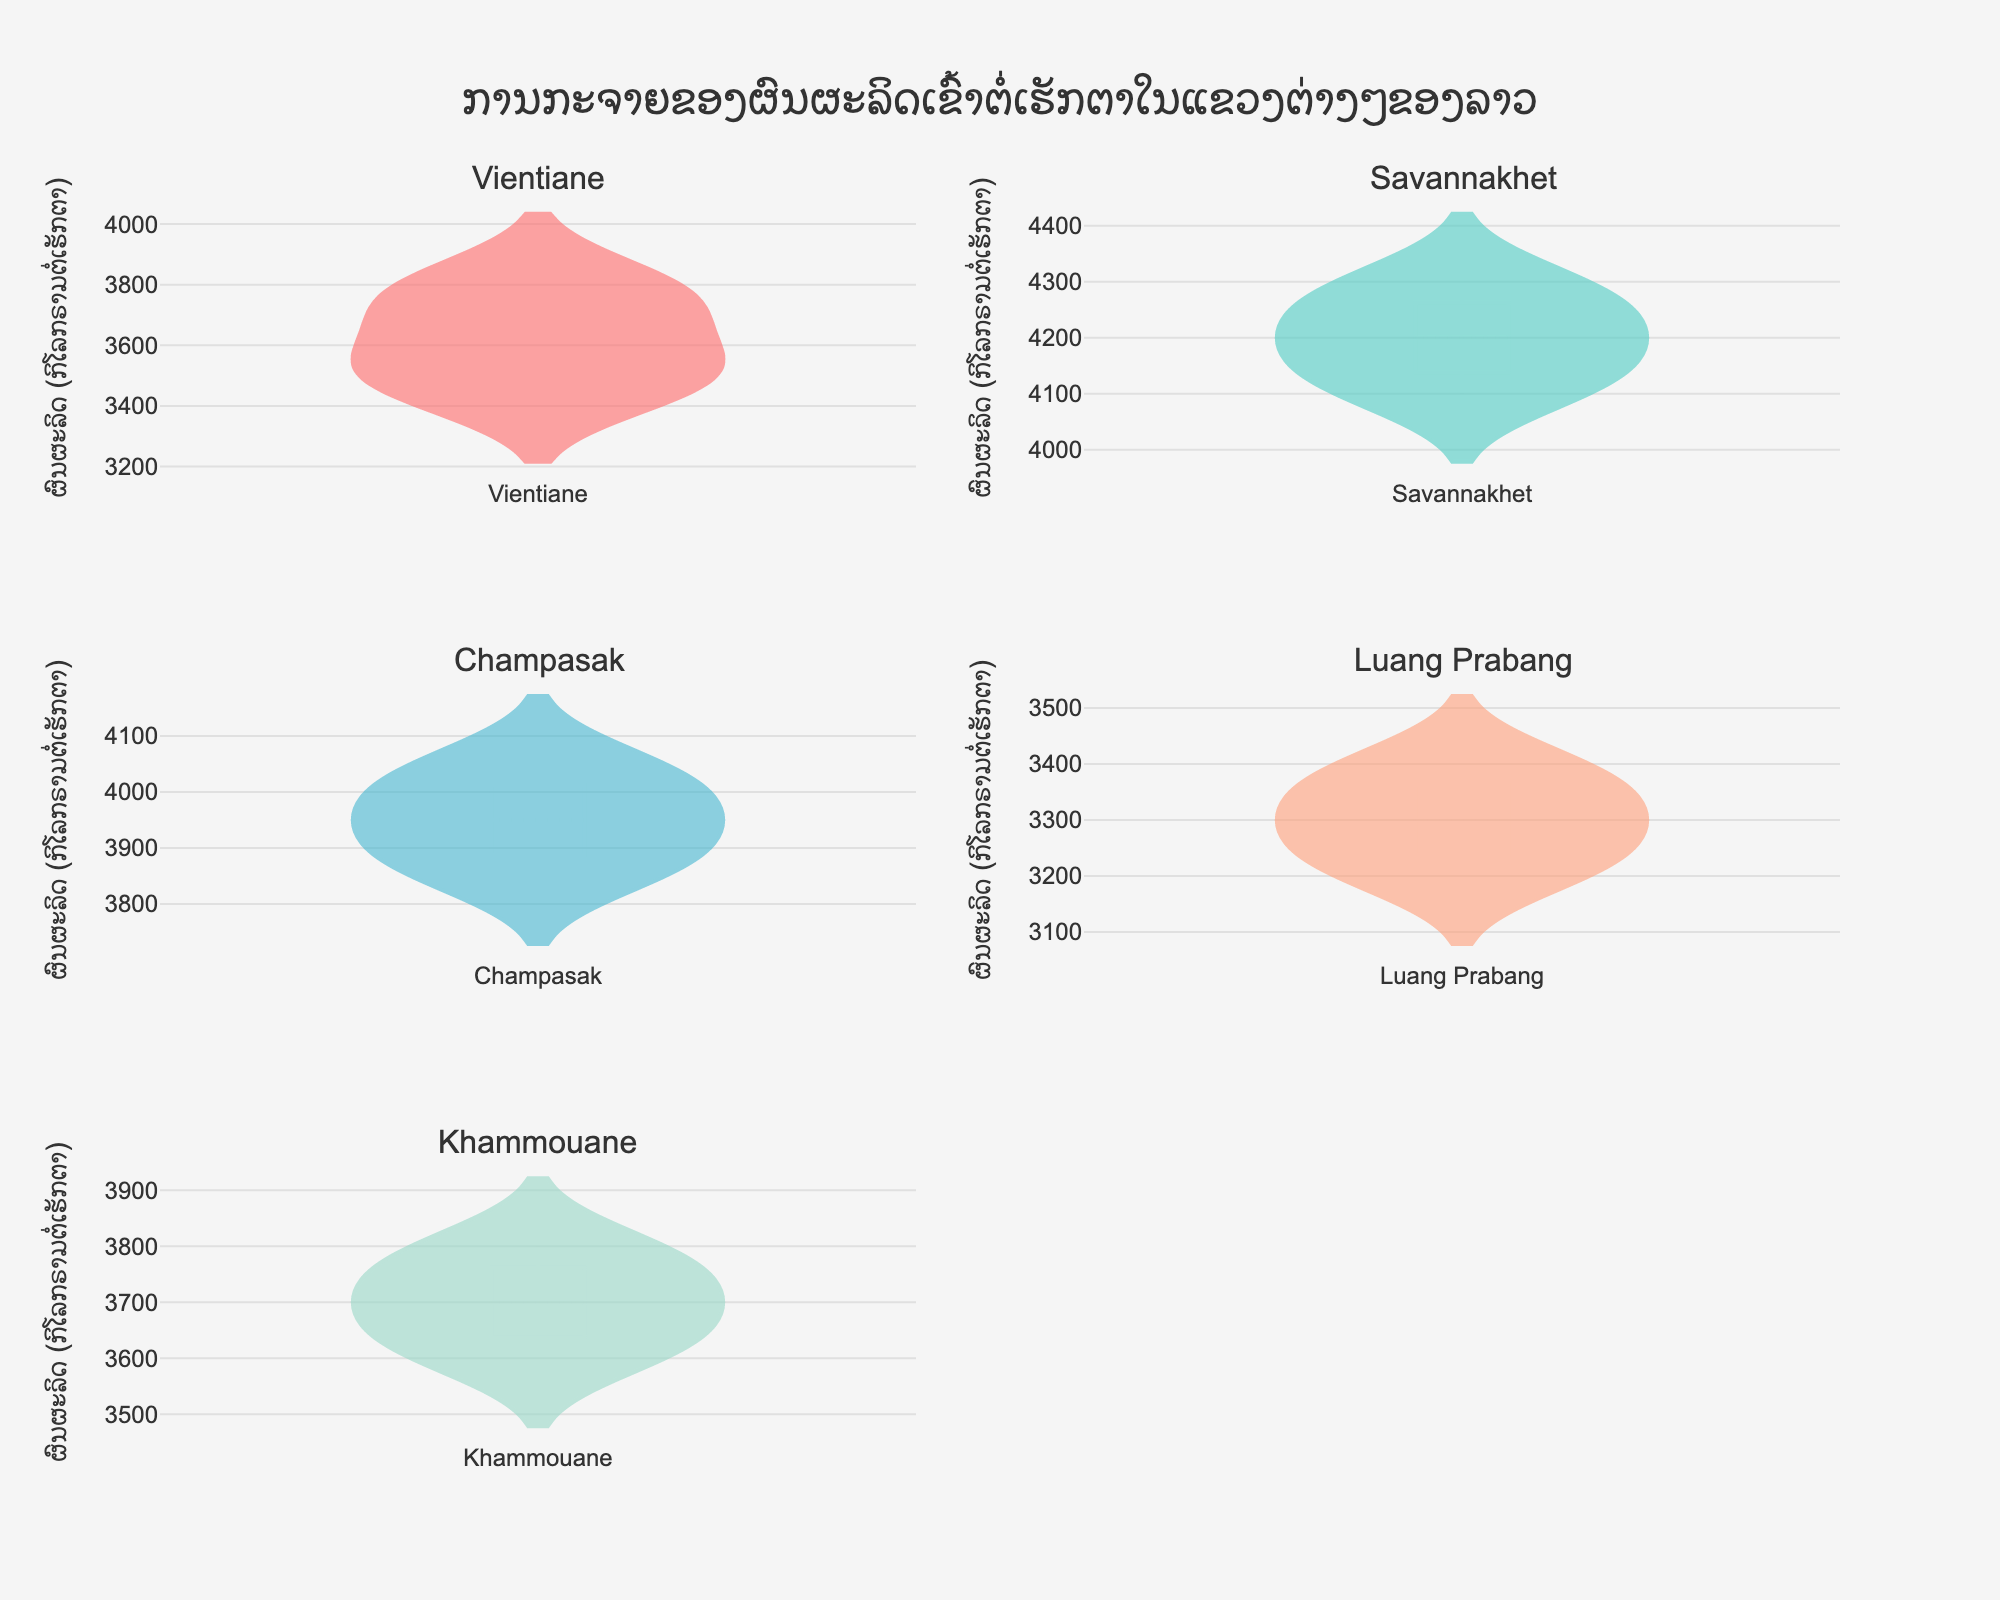What is the title of the figure? The title of the figure is displayed at the top and reads "ການກະຈາຍຂອງຜົນຜະລິດເຂົ້າຕໍ່ເຮັກຕາໃນແຂວງຕ່າງໆຂອງລາວ" which means "Distribution of rice yield per hectare in different provinces of Laos".
Answer: Distribution of rice yield per hectare in different provinces of Laos How many provinces are represented in the figure? Each subplot represents a different province, and since there are 5 subplots, there are 5 provinces. They are Vientiane, Savannakhet, Champasak, Luang Prabang, and Khammouane.
Answer: 5 Which province has the highest mean rice yield per hectare? By examining the mean line in each Violin plot, which is commonly shown as a horizontal line within each plot, we can see that Savannakhet has the highest mean rice yield.
Answer: Savannakhet Compare the rice yields of Luang Prabang and Vientiane. Which province has a higher median yield? The median of a Violin plot is usually shown with a line inside the box. Observing the median lines in both subplots, Vientiane shows a higher median yield compared to Luang Prabang.
Answer: Vientiane Is there any visible overlap in the rice yield range between Champasak and Khammouane? From the Violin plots of Champasak and Khammouane, we can see some visual overlap in their yield ranges. Both provinces have yields in the range of approximately 3600 to 4000 kg per hectare.
Answer: Yes Which province has the widest range of rice yields? The range can be observed by looking at the entire vertical span of the Violin plots. Savannakhet has the widest range, extending from approximately 4100 to 4300 kg per hectare.
Answer: Savannakhet What is the approximate rice yield value at the lower end of the distribution for Champasak province? The lower end of the distribution in the Champasak Violin plot is around 3850 kg per hectare.
Answer: 3850 kg per hectare Which province appears to have the most consistent rice yield (smallest variance)? The Violin plot with the narrowest spread indicates the most consistent yields. Luang Prabang's plot is the narrowest, indicating the smallest variance.
Answer: Luang Prabang What is the common color used in the Violin plot for data visualization, and do these colors have any particular significance? The Violin plots use distinct colors for each province: red, teal, light blue, light orange, and light green. These provide visual distinction but do not have specific inherent significance besides differentiating the provinces.
Answer: Distinct colors for each province 